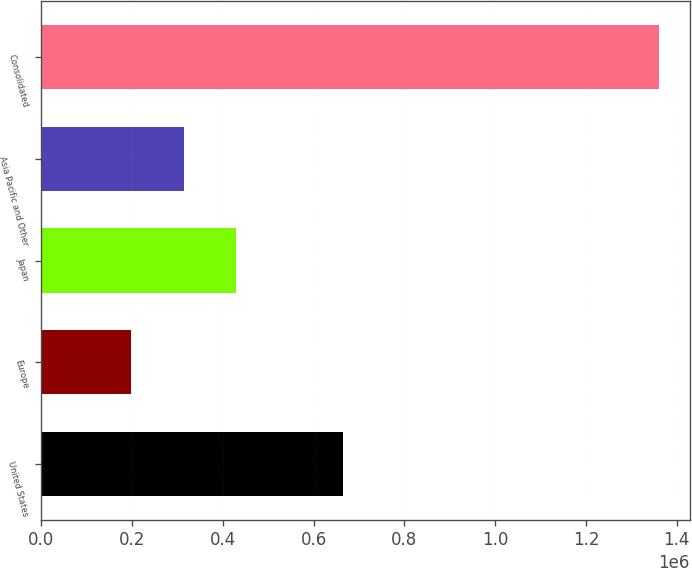Convert chart to OTSL. <chart><loc_0><loc_0><loc_500><loc_500><bar_chart><fcel>United States<fcel>Europe<fcel>Japan<fcel>Asia Pacific and Other<fcel>Consolidated<nl><fcel>664911<fcel>196916<fcel>429542<fcel>313229<fcel>1.36004e+06<nl></chart> 